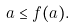<formula> <loc_0><loc_0><loc_500><loc_500>a \leq f ( a ) .</formula> 